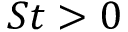<formula> <loc_0><loc_0><loc_500><loc_500>S t > 0</formula> 